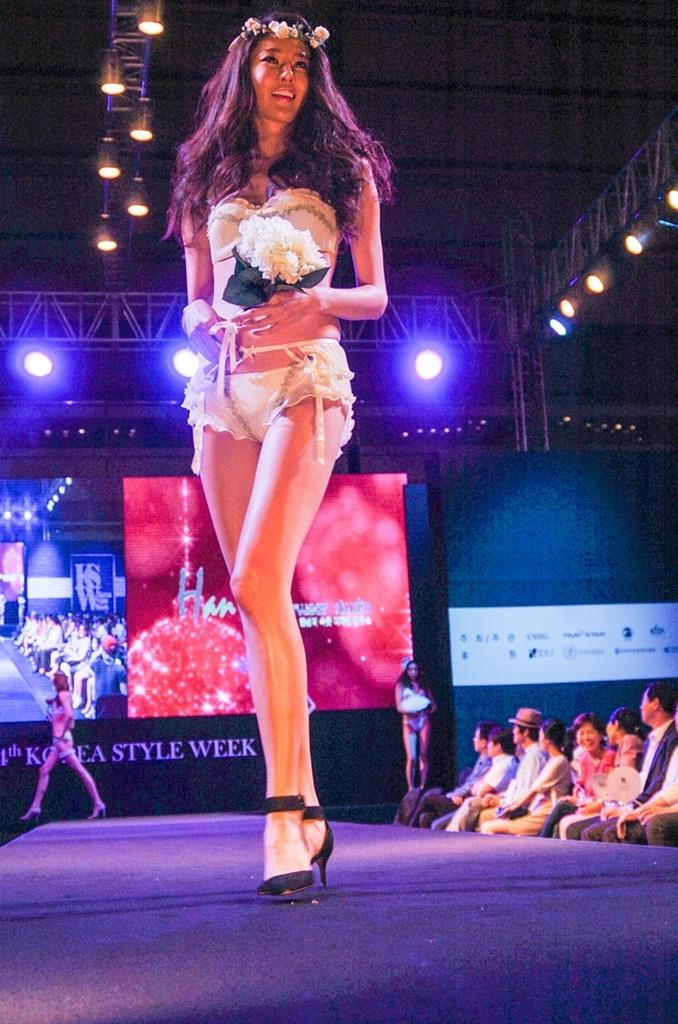What is the lady in the foreground of the image doing? The lady is standing in the foreground of the image and holding a bouquet. What can be seen in the background of the image? There is a screen in the background of the image, and two ladies are also visible. What are the people in the image doing near the ramp? People are sitting beside a ramp in the image. What type of jewel is the lady wearing in her hair in the image? There is no mention of a jewel or any hair accessories in the image, so it cannot be determined from the image. 